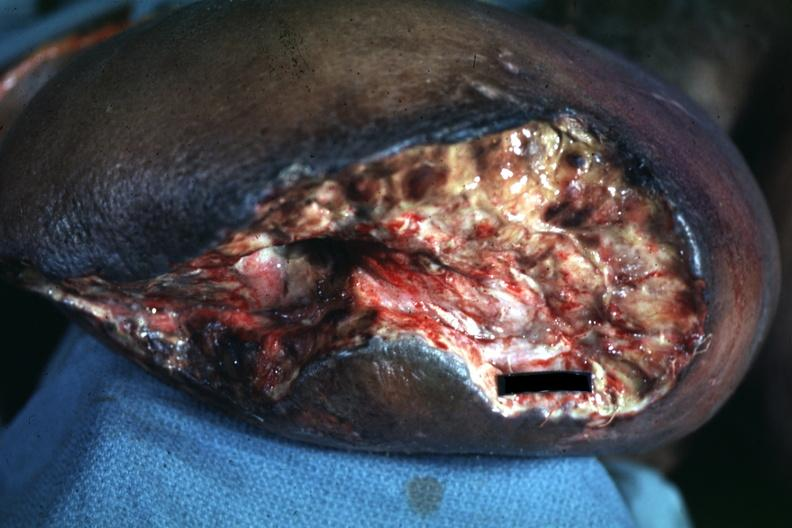re extremities present?
Answer the question using a single word or phrase. Yes 